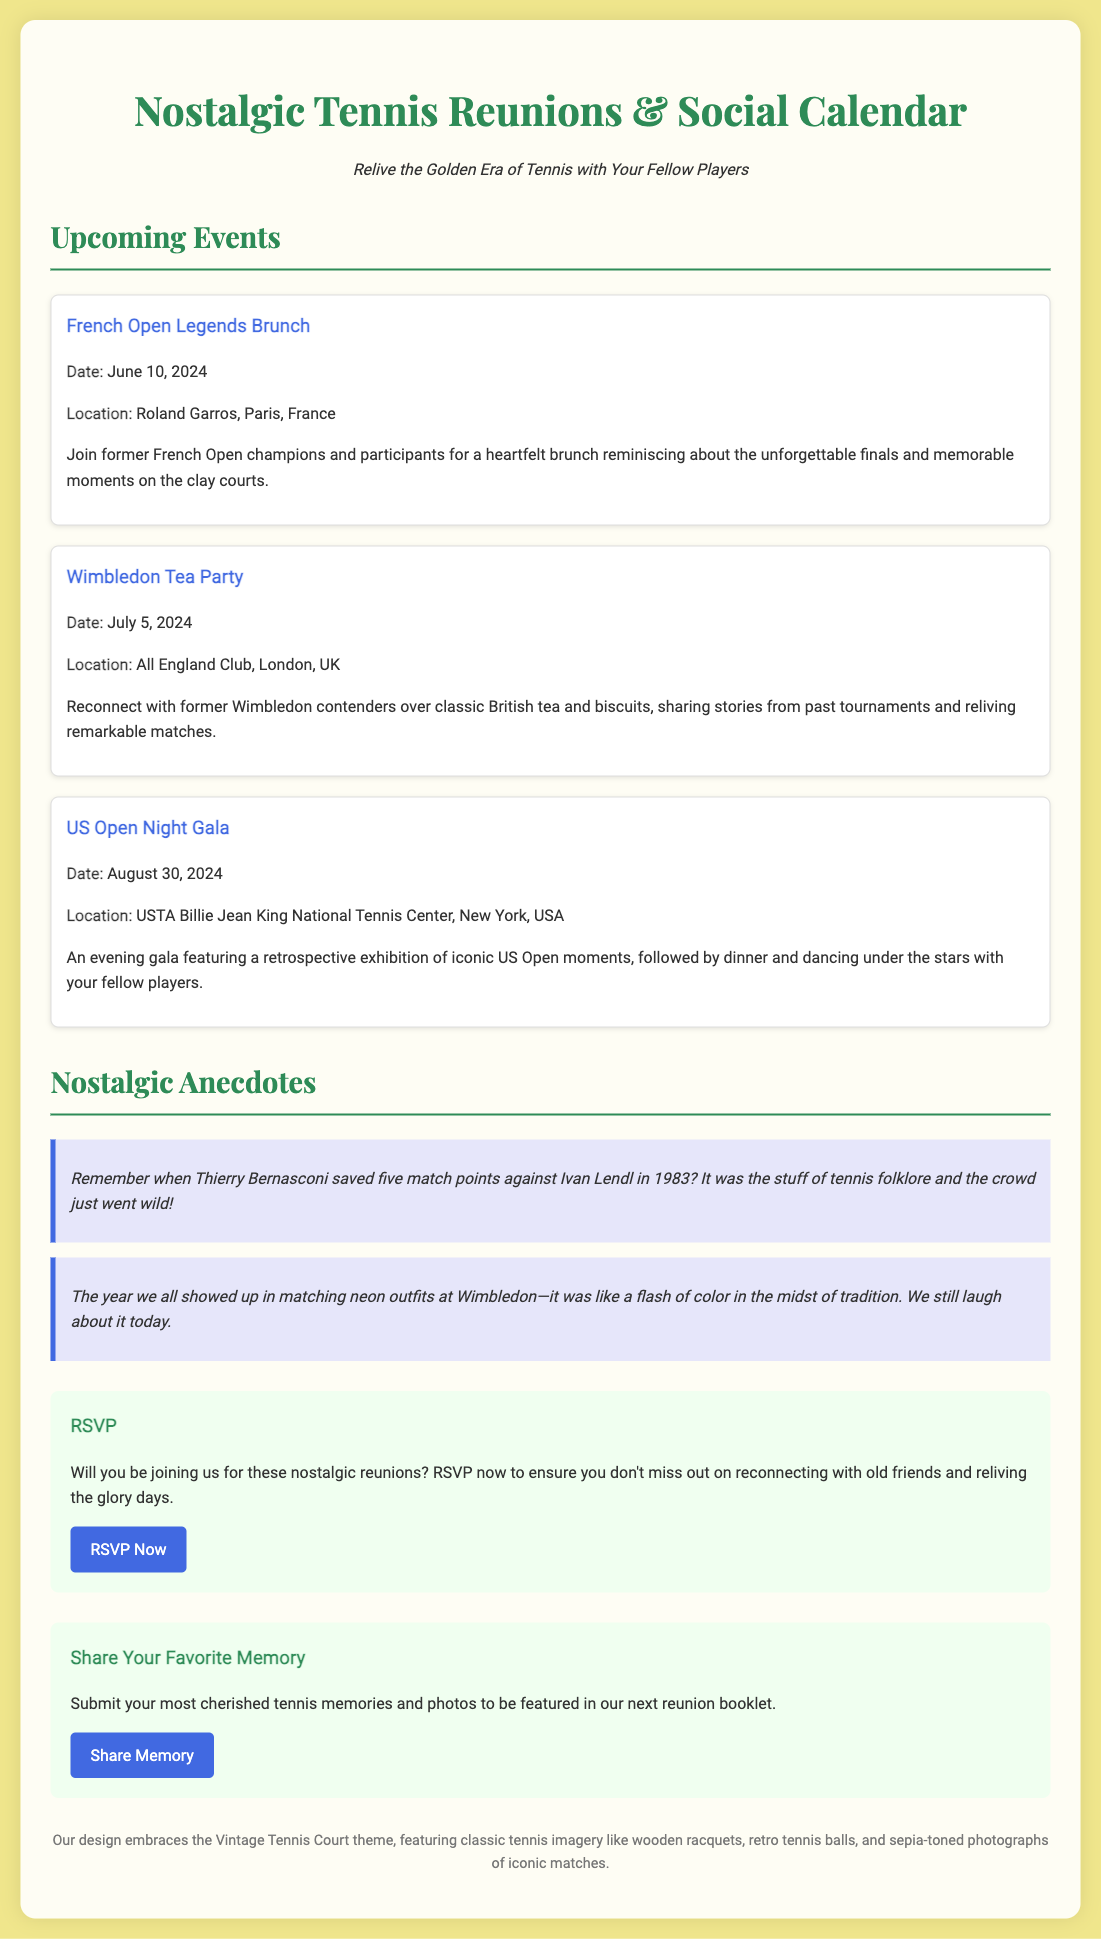what is the location of the French Open Legends Brunch? The French Open Legends Brunch is scheduled to be held at Roland Garros, Paris, France.
Answer: Roland Garros, Paris, France what is the date of the US Open Night Gala? The US Open Night Gala is set for August 30, 2024.
Answer: August 30, 2024 who is mentioned in the anecdote about saving match points against Ivan Lendl? The anecdote references Thierry Bernasconi saving five match points against Ivan Lendl in 1983.
Answer: Thierry Bernasconi how many nostalgic events are listed in the document? There are three nostalgic events mentioned in the document.
Answer: Three what is the title of the interactive section inviting people to submit memories? The title of the interactive section is "Share Your Favorite Memory."
Answer: Share Your Favorite Memory which club will host the Wimbledon Tea Party? The Wimbledon Tea Party will be hosted at the All England Club, London, UK.
Answer: All England Club, London, UK what type of atmosphere does the design of the document embrace? The design embraces a Vintage Tennis Court theme featuring classic tennis imagery.
Answer: Vintage Tennis Court theme what can attendees expect at the US Open Night Gala? Attendees can expect a retrospective exhibition of iconic US Open moments, followed by dinner and dancing.
Answer: Retrospective exhibition, dinner, and dancing 